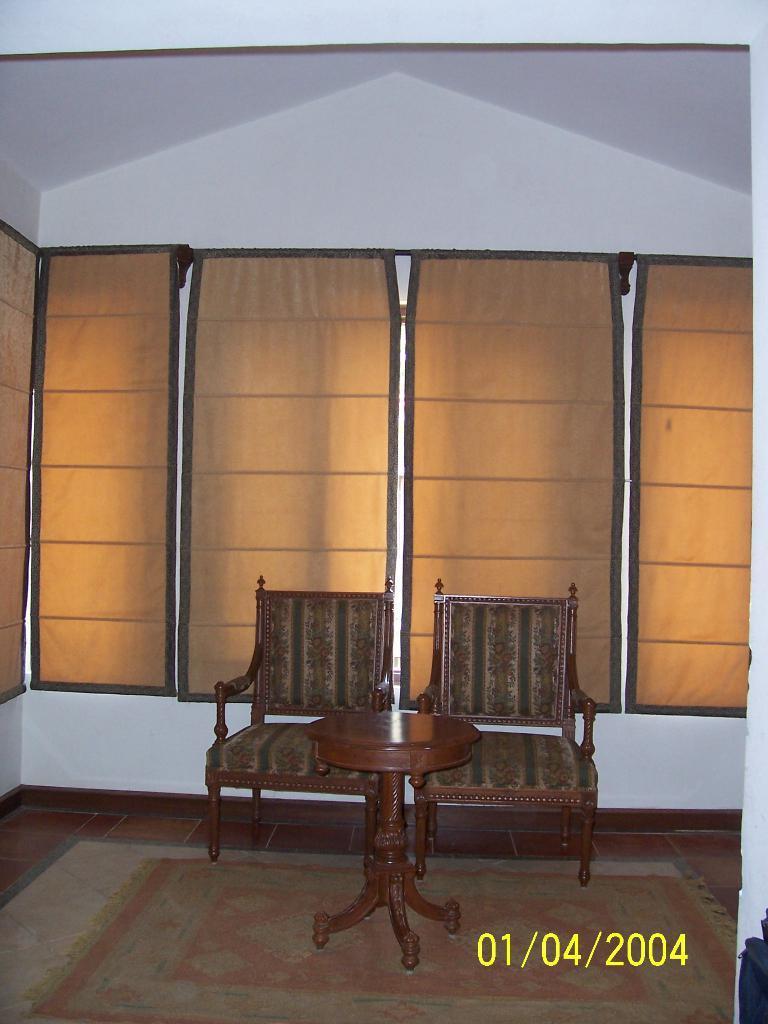Could you give a brief overview of what you see in this image? In this image I can see a table in the centre and behind it I can see two chairs and few cream colour curtains. I can also see a floor mattress on the floor and on the bottom right side of this image I can see a watermark. 